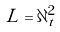Convert formula to latex. <formula><loc_0><loc_0><loc_500><loc_500>L = \partial _ { t } ^ { 2 }</formula> 